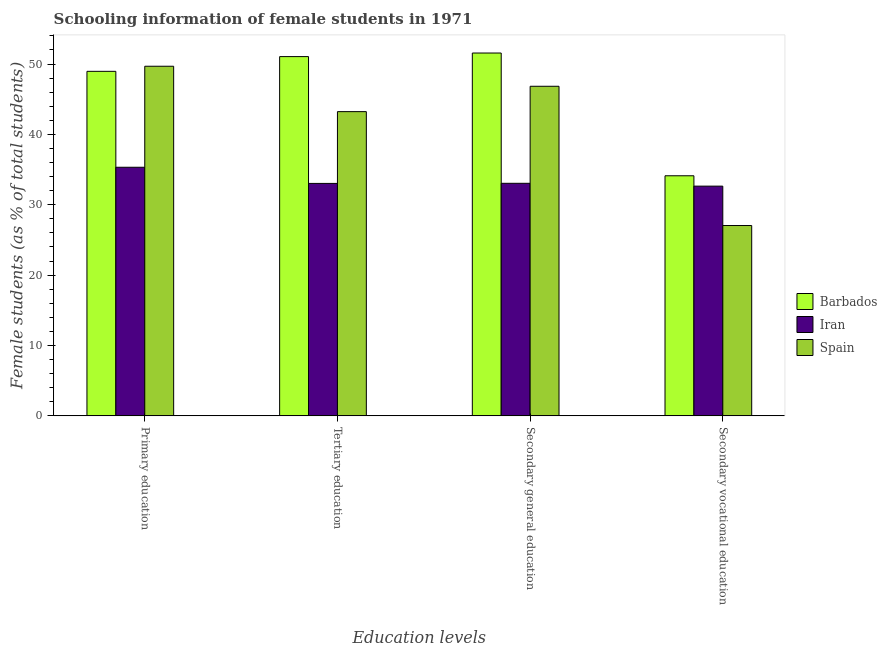How many groups of bars are there?
Provide a succinct answer. 4. How many bars are there on the 4th tick from the left?
Your answer should be compact. 3. How many bars are there on the 3rd tick from the right?
Keep it short and to the point. 3. What is the label of the 3rd group of bars from the left?
Offer a terse response. Secondary general education. What is the percentage of female students in secondary vocational education in Barbados?
Your response must be concise. 34.12. Across all countries, what is the maximum percentage of female students in secondary vocational education?
Provide a short and direct response. 34.12. Across all countries, what is the minimum percentage of female students in secondary education?
Provide a succinct answer. 33.05. In which country was the percentage of female students in primary education minimum?
Ensure brevity in your answer.  Iran. What is the total percentage of female students in primary education in the graph?
Keep it short and to the point. 133.97. What is the difference between the percentage of female students in secondary education in Iran and that in Spain?
Ensure brevity in your answer.  -13.79. What is the difference between the percentage of female students in secondary education in Iran and the percentage of female students in secondary vocational education in Spain?
Offer a terse response. 6. What is the average percentage of female students in secondary education per country?
Your answer should be very brief. 43.82. What is the difference between the percentage of female students in secondary vocational education and percentage of female students in primary education in Spain?
Your answer should be very brief. -22.63. In how many countries, is the percentage of female students in secondary education greater than 20 %?
Give a very brief answer. 3. What is the ratio of the percentage of female students in primary education in Iran to that in Barbados?
Keep it short and to the point. 0.72. Is the percentage of female students in primary education in Barbados less than that in Spain?
Your answer should be very brief. Yes. What is the difference between the highest and the second highest percentage of female students in primary education?
Provide a succinct answer. 0.72. What is the difference between the highest and the lowest percentage of female students in tertiary education?
Ensure brevity in your answer.  18.02. In how many countries, is the percentage of female students in primary education greater than the average percentage of female students in primary education taken over all countries?
Offer a very short reply. 2. Is the sum of the percentage of female students in primary education in Iran and Spain greater than the maximum percentage of female students in secondary education across all countries?
Provide a short and direct response. Yes. What does the 1st bar from the left in Secondary vocational education represents?
Your answer should be very brief. Barbados. What does the 3rd bar from the right in Primary education represents?
Keep it short and to the point. Barbados. Are all the bars in the graph horizontal?
Provide a succinct answer. No. Does the graph contain any zero values?
Make the answer very short. No. How are the legend labels stacked?
Keep it short and to the point. Vertical. What is the title of the graph?
Make the answer very short. Schooling information of female students in 1971. Does "Suriname" appear as one of the legend labels in the graph?
Keep it short and to the point. No. What is the label or title of the X-axis?
Your answer should be compact. Education levels. What is the label or title of the Y-axis?
Your answer should be very brief. Female students (as % of total students). What is the Female students (as % of total students) of Barbados in Primary education?
Make the answer very short. 48.96. What is the Female students (as % of total students) in Iran in Primary education?
Offer a terse response. 35.33. What is the Female students (as % of total students) of Spain in Primary education?
Offer a terse response. 49.68. What is the Female students (as % of total students) of Barbados in Tertiary education?
Offer a terse response. 51.05. What is the Female students (as % of total students) of Iran in Tertiary education?
Provide a succinct answer. 33.03. What is the Female students (as % of total students) of Spain in Tertiary education?
Ensure brevity in your answer.  43.23. What is the Female students (as % of total students) of Barbados in Secondary general education?
Offer a terse response. 51.56. What is the Female students (as % of total students) of Iran in Secondary general education?
Your response must be concise. 33.05. What is the Female students (as % of total students) of Spain in Secondary general education?
Ensure brevity in your answer.  46.84. What is the Female students (as % of total students) in Barbados in Secondary vocational education?
Provide a succinct answer. 34.12. What is the Female students (as % of total students) in Iran in Secondary vocational education?
Make the answer very short. 32.65. What is the Female students (as % of total students) in Spain in Secondary vocational education?
Provide a short and direct response. 27.05. Across all Education levels, what is the maximum Female students (as % of total students) of Barbados?
Your answer should be compact. 51.56. Across all Education levels, what is the maximum Female students (as % of total students) of Iran?
Make the answer very short. 35.33. Across all Education levels, what is the maximum Female students (as % of total students) of Spain?
Offer a very short reply. 49.68. Across all Education levels, what is the minimum Female students (as % of total students) of Barbados?
Ensure brevity in your answer.  34.12. Across all Education levels, what is the minimum Female students (as % of total students) in Iran?
Your answer should be very brief. 32.65. Across all Education levels, what is the minimum Female students (as % of total students) of Spain?
Your answer should be very brief. 27.05. What is the total Female students (as % of total students) of Barbados in the graph?
Offer a terse response. 185.69. What is the total Female students (as % of total students) of Iran in the graph?
Make the answer very short. 134.06. What is the total Female students (as % of total students) of Spain in the graph?
Offer a terse response. 166.8. What is the difference between the Female students (as % of total students) in Barbados in Primary education and that in Tertiary education?
Your response must be concise. -2.09. What is the difference between the Female students (as % of total students) of Iran in Primary education and that in Tertiary education?
Offer a terse response. 2.3. What is the difference between the Female students (as % of total students) of Spain in Primary education and that in Tertiary education?
Your response must be concise. 6.45. What is the difference between the Female students (as % of total students) of Barbados in Primary education and that in Secondary general education?
Keep it short and to the point. -2.6. What is the difference between the Female students (as % of total students) of Iran in Primary education and that in Secondary general education?
Offer a terse response. 2.28. What is the difference between the Female students (as % of total students) in Spain in Primary education and that in Secondary general education?
Provide a succinct answer. 2.85. What is the difference between the Female students (as % of total students) in Barbados in Primary education and that in Secondary vocational education?
Your response must be concise. 14.84. What is the difference between the Female students (as % of total students) in Iran in Primary education and that in Secondary vocational education?
Make the answer very short. 2.68. What is the difference between the Female students (as % of total students) in Spain in Primary education and that in Secondary vocational education?
Offer a terse response. 22.63. What is the difference between the Female students (as % of total students) of Barbados in Tertiary education and that in Secondary general education?
Give a very brief answer. -0.51. What is the difference between the Female students (as % of total students) of Iran in Tertiary education and that in Secondary general education?
Offer a terse response. -0.02. What is the difference between the Female students (as % of total students) of Spain in Tertiary education and that in Secondary general education?
Offer a terse response. -3.6. What is the difference between the Female students (as % of total students) of Barbados in Tertiary education and that in Secondary vocational education?
Provide a short and direct response. 16.93. What is the difference between the Female students (as % of total students) of Iran in Tertiary education and that in Secondary vocational education?
Your answer should be very brief. 0.39. What is the difference between the Female students (as % of total students) of Spain in Tertiary education and that in Secondary vocational education?
Offer a very short reply. 16.19. What is the difference between the Female students (as % of total students) of Barbados in Secondary general education and that in Secondary vocational education?
Your answer should be very brief. 17.44. What is the difference between the Female students (as % of total students) of Iran in Secondary general education and that in Secondary vocational education?
Provide a succinct answer. 0.4. What is the difference between the Female students (as % of total students) in Spain in Secondary general education and that in Secondary vocational education?
Provide a succinct answer. 19.79. What is the difference between the Female students (as % of total students) of Barbados in Primary education and the Female students (as % of total students) of Iran in Tertiary education?
Offer a very short reply. 15.93. What is the difference between the Female students (as % of total students) of Barbados in Primary education and the Female students (as % of total students) of Spain in Tertiary education?
Offer a very short reply. 5.73. What is the difference between the Female students (as % of total students) of Iran in Primary education and the Female students (as % of total students) of Spain in Tertiary education?
Give a very brief answer. -7.9. What is the difference between the Female students (as % of total students) of Barbados in Primary education and the Female students (as % of total students) of Iran in Secondary general education?
Provide a succinct answer. 15.91. What is the difference between the Female students (as % of total students) in Barbados in Primary education and the Female students (as % of total students) in Spain in Secondary general education?
Offer a very short reply. 2.12. What is the difference between the Female students (as % of total students) of Iran in Primary education and the Female students (as % of total students) of Spain in Secondary general education?
Your response must be concise. -11.51. What is the difference between the Female students (as % of total students) in Barbados in Primary education and the Female students (as % of total students) in Iran in Secondary vocational education?
Keep it short and to the point. 16.31. What is the difference between the Female students (as % of total students) of Barbados in Primary education and the Female students (as % of total students) of Spain in Secondary vocational education?
Make the answer very short. 21.91. What is the difference between the Female students (as % of total students) in Iran in Primary education and the Female students (as % of total students) in Spain in Secondary vocational education?
Your answer should be compact. 8.28. What is the difference between the Female students (as % of total students) of Barbados in Tertiary education and the Female students (as % of total students) of Iran in Secondary general education?
Your response must be concise. 18. What is the difference between the Female students (as % of total students) of Barbados in Tertiary education and the Female students (as % of total students) of Spain in Secondary general education?
Make the answer very short. 4.22. What is the difference between the Female students (as % of total students) in Iran in Tertiary education and the Female students (as % of total students) in Spain in Secondary general education?
Offer a very short reply. -13.8. What is the difference between the Female students (as % of total students) in Barbados in Tertiary education and the Female students (as % of total students) in Iran in Secondary vocational education?
Provide a succinct answer. 18.41. What is the difference between the Female students (as % of total students) of Barbados in Tertiary education and the Female students (as % of total students) of Spain in Secondary vocational education?
Offer a very short reply. 24. What is the difference between the Female students (as % of total students) of Iran in Tertiary education and the Female students (as % of total students) of Spain in Secondary vocational education?
Provide a short and direct response. 5.98. What is the difference between the Female students (as % of total students) in Barbados in Secondary general education and the Female students (as % of total students) in Iran in Secondary vocational education?
Provide a succinct answer. 18.92. What is the difference between the Female students (as % of total students) of Barbados in Secondary general education and the Female students (as % of total students) of Spain in Secondary vocational education?
Your answer should be compact. 24.51. What is the difference between the Female students (as % of total students) in Iran in Secondary general education and the Female students (as % of total students) in Spain in Secondary vocational education?
Offer a terse response. 6. What is the average Female students (as % of total students) of Barbados per Education levels?
Ensure brevity in your answer.  46.42. What is the average Female students (as % of total students) of Iran per Education levels?
Keep it short and to the point. 33.51. What is the average Female students (as % of total students) in Spain per Education levels?
Ensure brevity in your answer.  41.7. What is the difference between the Female students (as % of total students) of Barbados and Female students (as % of total students) of Iran in Primary education?
Keep it short and to the point. 13.63. What is the difference between the Female students (as % of total students) in Barbados and Female students (as % of total students) in Spain in Primary education?
Provide a succinct answer. -0.72. What is the difference between the Female students (as % of total students) of Iran and Female students (as % of total students) of Spain in Primary education?
Your answer should be compact. -14.35. What is the difference between the Female students (as % of total students) in Barbados and Female students (as % of total students) in Iran in Tertiary education?
Your answer should be compact. 18.02. What is the difference between the Female students (as % of total students) in Barbados and Female students (as % of total students) in Spain in Tertiary education?
Your answer should be compact. 7.82. What is the difference between the Female students (as % of total students) of Iran and Female students (as % of total students) of Spain in Tertiary education?
Offer a very short reply. -10.2. What is the difference between the Female students (as % of total students) in Barbados and Female students (as % of total students) in Iran in Secondary general education?
Ensure brevity in your answer.  18.51. What is the difference between the Female students (as % of total students) of Barbados and Female students (as % of total students) of Spain in Secondary general education?
Give a very brief answer. 4.73. What is the difference between the Female students (as % of total students) in Iran and Female students (as % of total students) in Spain in Secondary general education?
Your answer should be very brief. -13.79. What is the difference between the Female students (as % of total students) in Barbados and Female students (as % of total students) in Iran in Secondary vocational education?
Give a very brief answer. 1.47. What is the difference between the Female students (as % of total students) in Barbados and Female students (as % of total students) in Spain in Secondary vocational education?
Give a very brief answer. 7.07. What is the difference between the Female students (as % of total students) in Iran and Female students (as % of total students) in Spain in Secondary vocational education?
Ensure brevity in your answer.  5.6. What is the ratio of the Female students (as % of total students) in Iran in Primary education to that in Tertiary education?
Offer a terse response. 1.07. What is the ratio of the Female students (as % of total students) of Spain in Primary education to that in Tertiary education?
Offer a very short reply. 1.15. What is the ratio of the Female students (as % of total students) of Barbados in Primary education to that in Secondary general education?
Offer a terse response. 0.95. What is the ratio of the Female students (as % of total students) in Iran in Primary education to that in Secondary general education?
Make the answer very short. 1.07. What is the ratio of the Female students (as % of total students) of Spain in Primary education to that in Secondary general education?
Ensure brevity in your answer.  1.06. What is the ratio of the Female students (as % of total students) in Barbados in Primary education to that in Secondary vocational education?
Ensure brevity in your answer.  1.43. What is the ratio of the Female students (as % of total students) of Iran in Primary education to that in Secondary vocational education?
Offer a very short reply. 1.08. What is the ratio of the Female students (as % of total students) in Spain in Primary education to that in Secondary vocational education?
Your answer should be very brief. 1.84. What is the ratio of the Female students (as % of total students) in Barbados in Tertiary education to that in Secondary general education?
Offer a terse response. 0.99. What is the ratio of the Female students (as % of total students) in Iran in Tertiary education to that in Secondary general education?
Your answer should be compact. 1. What is the ratio of the Female students (as % of total students) of Barbados in Tertiary education to that in Secondary vocational education?
Provide a short and direct response. 1.5. What is the ratio of the Female students (as % of total students) in Iran in Tertiary education to that in Secondary vocational education?
Your answer should be very brief. 1.01. What is the ratio of the Female students (as % of total students) of Spain in Tertiary education to that in Secondary vocational education?
Give a very brief answer. 1.6. What is the ratio of the Female students (as % of total students) of Barbados in Secondary general education to that in Secondary vocational education?
Provide a succinct answer. 1.51. What is the ratio of the Female students (as % of total students) of Iran in Secondary general education to that in Secondary vocational education?
Offer a very short reply. 1.01. What is the ratio of the Female students (as % of total students) of Spain in Secondary general education to that in Secondary vocational education?
Give a very brief answer. 1.73. What is the difference between the highest and the second highest Female students (as % of total students) in Barbados?
Provide a succinct answer. 0.51. What is the difference between the highest and the second highest Female students (as % of total students) in Iran?
Your answer should be very brief. 2.28. What is the difference between the highest and the second highest Female students (as % of total students) in Spain?
Give a very brief answer. 2.85. What is the difference between the highest and the lowest Female students (as % of total students) of Barbados?
Provide a short and direct response. 17.44. What is the difference between the highest and the lowest Female students (as % of total students) in Iran?
Your answer should be very brief. 2.68. What is the difference between the highest and the lowest Female students (as % of total students) of Spain?
Offer a very short reply. 22.63. 